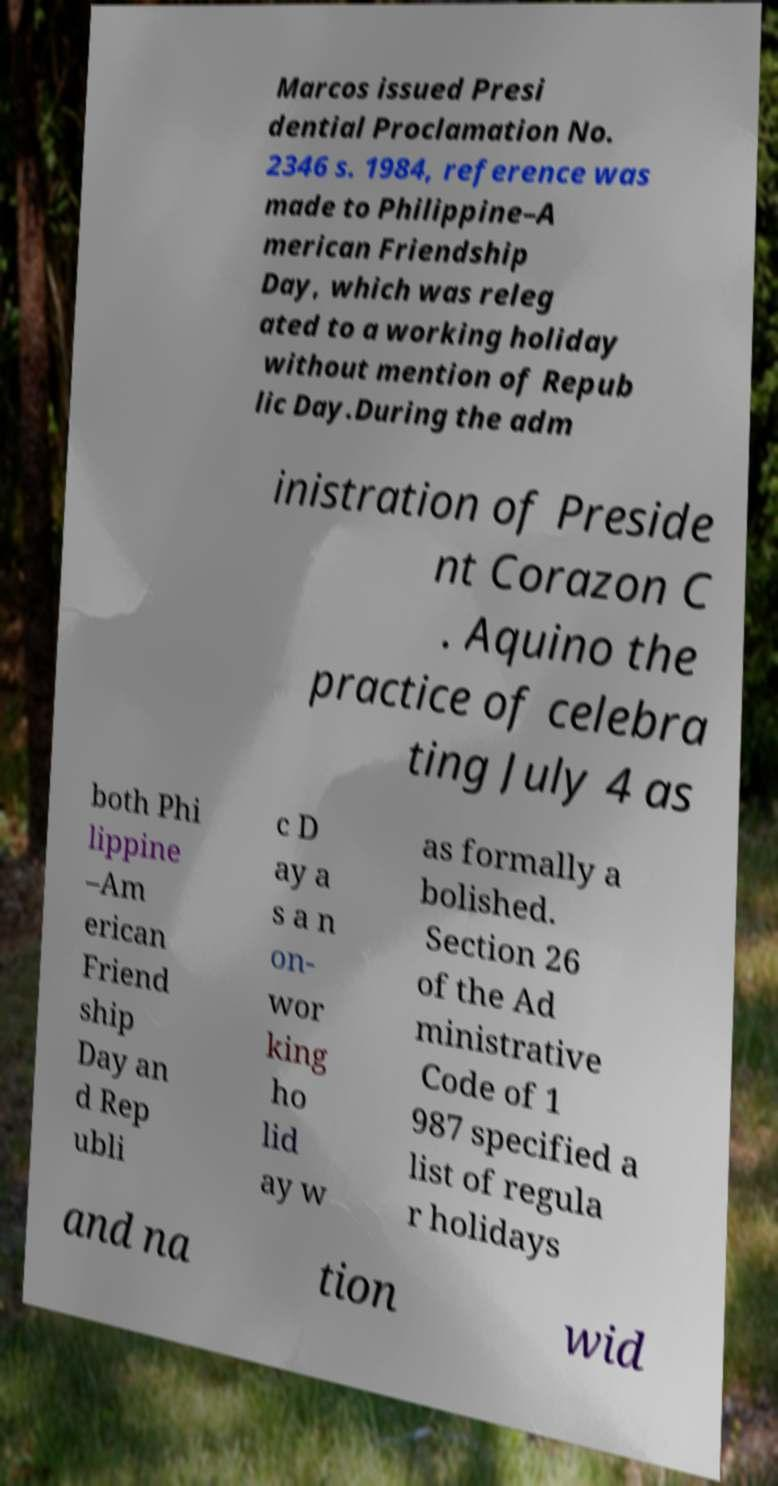Could you assist in decoding the text presented in this image and type it out clearly? Marcos issued Presi dential Proclamation No. 2346 s. 1984, reference was made to Philippine–A merican Friendship Day, which was releg ated to a working holiday without mention of Repub lic Day.During the adm inistration of Preside nt Corazon C . Aquino the practice of celebra ting July 4 as both Phi lippine –Am erican Friend ship Day an d Rep ubli c D ay a s a n on- wor king ho lid ay w as formally a bolished. Section 26 of the Ad ministrative Code of 1 987 specified a list of regula r holidays and na tion wid 